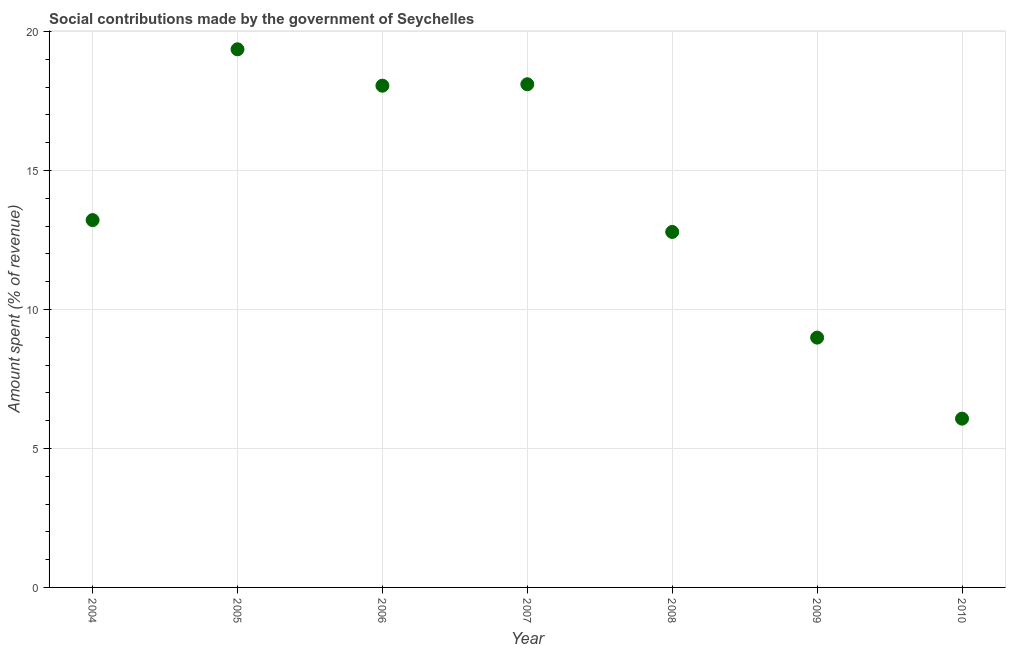What is the amount spent in making social contributions in 2007?
Offer a very short reply. 18.1. Across all years, what is the maximum amount spent in making social contributions?
Provide a short and direct response. 19.36. Across all years, what is the minimum amount spent in making social contributions?
Provide a short and direct response. 6.07. In which year was the amount spent in making social contributions maximum?
Give a very brief answer. 2005. In which year was the amount spent in making social contributions minimum?
Offer a very short reply. 2010. What is the sum of the amount spent in making social contributions?
Provide a succinct answer. 96.59. What is the difference between the amount spent in making social contributions in 2007 and 2009?
Offer a very short reply. 9.12. What is the average amount spent in making social contributions per year?
Your answer should be compact. 13.8. What is the median amount spent in making social contributions?
Offer a terse response. 13.22. In how many years, is the amount spent in making social contributions greater than 7 %?
Give a very brief answer. 6. Do a majority of the years between 2008 and 2005 (inclusive) have amount spent in making social contributions greater than 4 %?
Make the answer very short. Yes. What is the ratio of the amount spent in making social contributions in 2006 to that in 2010?
Offer a very short reply. 2.97. Is the amount spent in making social contributions in 2006 less than that in 2010?
Give a very brief answer. No. What is the difference between the highest and the second highest amount spent in making social contributions?
Ensure brevity in your answer.  1.26. What is the difference between the highest and the lowest amount spent in making social contributions?
Offer a terse response. 13.29. Does the amount spent in making social contributions monotonically increase over the years?
Your answer should be compact. No. How many dotlines are there?
Your answer should be very brief. 1. How many years are there in the graph?
Give a very brief answer. 7. Are the values on the major ticks of Y-axis written in scientific E-notation?
Offer a very short reply. No. Does the graph contain any zero values?
Provide a succinct answer. No. What is the title of the graph?
Make the answer very short. Social contributions made by the government of Seychelles. What is the label or title of the Y-axis?
Your answer should be compact. Amount spent (% of revenue). What is the Amount spent (% of revenue) in 2004?
Keep it short and to the point. 13.22. What is the Amount spent (% of revenue) in 2005?
Give a very brief answer. 19.36. What is the Amount spent (% of revenue) in 2006?
Keep it short and to the point. 18.05. What is the Amount spent (% of revenue) in 2007?
Make the answer very short. 18.1. What is the Amount spent (% of revenue) in 2008?
Provide a succinct answer. 12.79. What is the Amount spent (% of revenue) in 2009?
Offer a very short reply. 8.99. What is the Amount spent (% of revenue) in 2010?
Offer a very short reply. 6.07. What is the difference between the Amount spent (% of revenue) in 2004 and 2005?
Offer a very short reply. -6.15. What is the difference between the Amount spent (% of revenue) in 2004 and 2006?
Provide a short and direct response. -4.84. What is the difference between the Amount spent (% of revenue) in 2004 and 2007?
Provide a succinct answer. -4.89. What is the difference between the Amount spent (% of revenue) in 2004 and 2008?
Provide a succinct answer. 0.43. What is the difference between the Amount spent (% of revenue) in 2004 and 2009?
Your answer should be compact. 4.23. What is the difference between the Amount spent (% of revenue) in 2004 and 2010?
Offer a very short reply. 7.14. What is the difference between the Amount spent (% of revenue) in 2005 and 2006?
Give a very brief answer. 1.31. What is the difference between the Amount spent (% of revenue) in 2005 and 2007?
Keep it short and to the point. 1.26. What is the difference between the Amount spent (% of revenue) in 2005 and 2008?
Make the answer very short. 6.57. What is the difference between the Amount spent (% of revenue) in 2005 and 2009?
Ensure brevity in your answer.  10.37. What is the difference between the Amount spent (% of revenue) in 2005 and 2010?
Your answer should be compact. 13.29. What is the difference between the Amount spent (% of revenue) in 2006 and 2007?
Keep it short and to the point. -0.05. What is the difference between the Amount spent (% of revenue) in 2006 and 2008?
Make the answer very short. 5.26. What is the difference between the Amount spent (% of revenue) in 2006 and 2009?
Offer a very short reply. 9.06. What is the difference between the Amount spent (% of revenue) in 2006 and 2010?
Your response must be concise. 11.98. What is the difference between the Amount spent (% of revenue) in 2007 and 2008?
Your answer should be compact. 5.31. What is the difference between the Amount spent (% of revenue) in 2007 and 2009?
Ensure brevity in your answer.  9.12. What is the difference between the Amount spent (% of revenue) in 2007 and 2010?
Keep it short and to the point. 12.03. What is the difference between the Amount spent (% of revenue) in 2008 and 2009?
Give a very brief answer. 3.8. What is the difference between the Amount spent (% of revenue) in 2008 and 2010?
Provide a succinct answer. 6.72. What is the difference between the Amount spent (% of revenue) in 2009 and 2010?
Give a very brief answer. 2.92. What is the ratio of the Amount spent (% of revenue) in 2004 to that in 2005?
Offer a terse response. 0.68. What is the ratio of the Amount spent (% of revenue) in 2004 to that in 2006?
Ensure brevity in your answer.  0.73. What is the ratio of the Amount spent (% of revenue) in 2004 to that in 2007?
Your answer should be very brief. 0.73. What is the ratio of the Amount spent (% of revenue) in 2004 to that in 2008?
Provide a short and direct response. 1.03. What is the ratio of the Amount spent (% of revenue) in 2004 to that in 2009?
Provide a short and direct response. 1.47. What is the ratio of the Amount spent (% of revenue) in 2004 to that in 2010?
Keep it short and to the point. 2.18. What is the ratio of the Amount spent (% of revenue) in 2005 to that in 2006?
Your answer should be compact. 1.07. What is the ratio of the Amount spent (% of revenue) in 2005 to that in 2007?
Offer a terse response. 1.07. What is the ratio of the Amount spent (% of revenue) in 2005 to that in 2008?
Make the answer very short. 1.51. What is the ratio of the Amount spent (% of revenue) in 2005 to that in 2009?
Give a very brief answer. 2.15. What is the ratio of the Amount spent (% of revenue) in 2005 to that in 2010?
Provide a short and direct response. 3.19. What is the ratio of the Amount spent (% of revenue) in 2006 to that in 2007?
Make the answer very short. 1. What is the ratio of the Amount spent (% of revenue) in 2006 to that in 2008?
Offer a very short reply. 1.41. What is the ratio of the Amount spent (% of revenue) in 2006 to that in 2009?
Provide a succinct answer. 2.01. What is the ratio of the Amount spent (% of revenue) in 2006 to that in 2010?
Offer a very short reply. 2.97. What is the ratio of the Amount spent (% of revenue) in 2007 to that in 2008?
Your response must be concise. 1.42. What is the ratio of the Amount spent (% of revenue) in 2007 to that in 2009?
Keep it short and to the point. 2.01. What is the ratio of the Amount spent (% of revenue) in 2007 to that in 2010?
Ensure brevity in your answer.  2.98. What is the ratio of the Amount spent (% of revenue) in 2008 to that in 2009?
Offer a terse response. 1.42. What is the ratio of the Amount spent (% of revenue) in 2008 to that in 2010?
Ensure brevity in your answer.  2.11. What is the ratio of the Amount spent (% of revenue) in 2009 to that in 2010?
Offer a terse response. 1.48. 